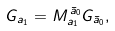Convert formula to latex. <formula><loc_0><loc_0><loc_500><loc_500>G _ { a _ { 1 } } = M _ { a _ { 1 } } ^ { \, \bar { a } _ { 0 } } G _ { \bar { a } _ { 0 } } ,</formula> 